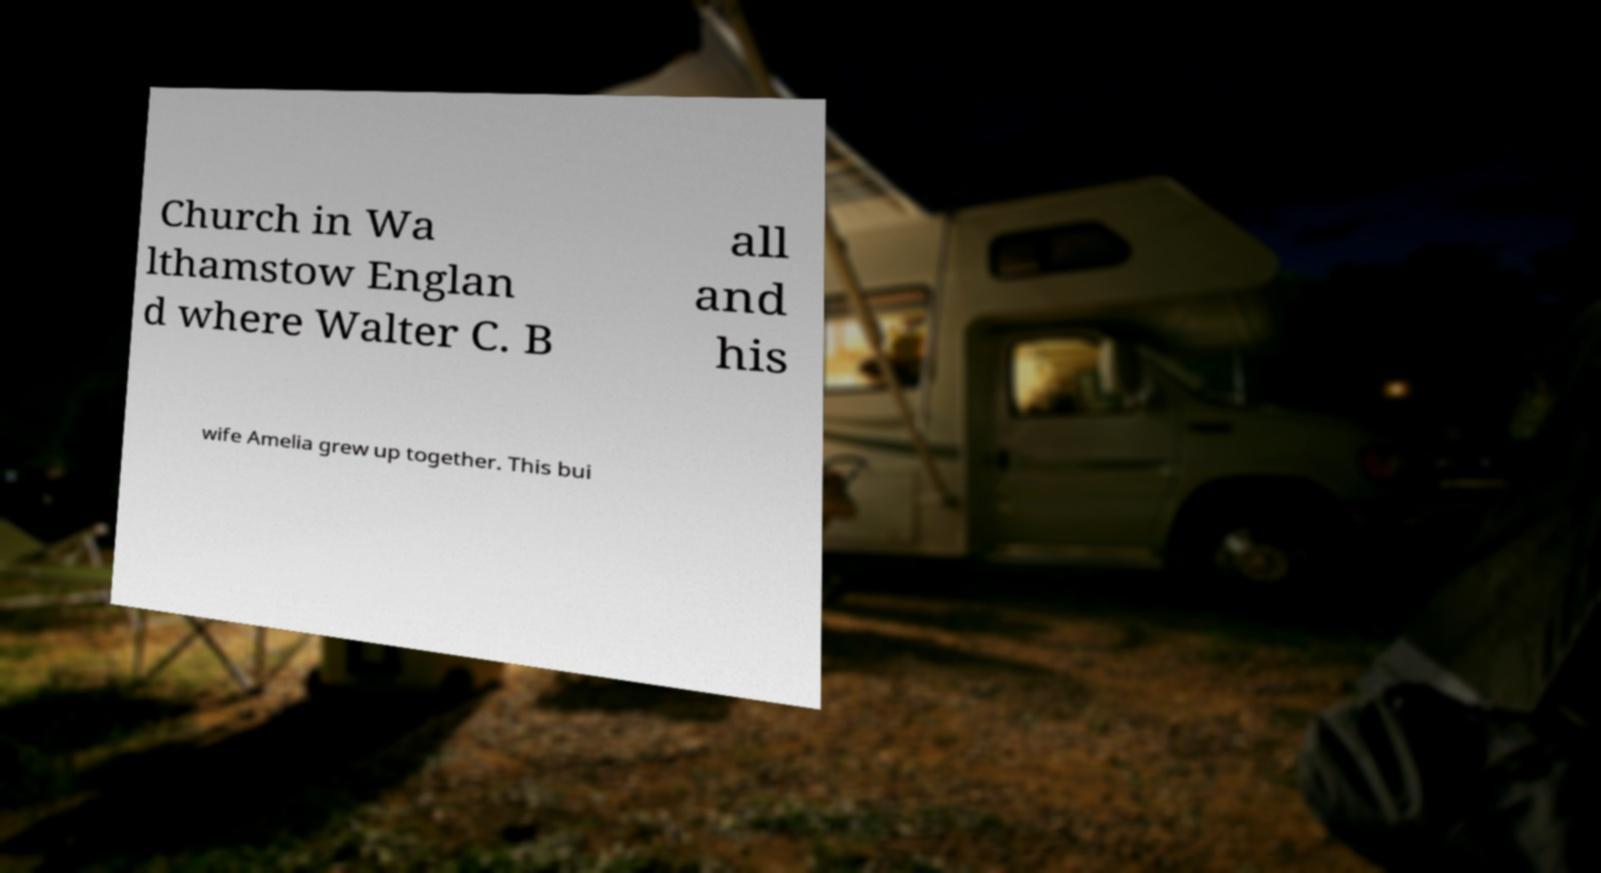Could you extract and type out the text from this image? Church in Wa lthamstow Englan d where Walter C. B all and his wife Amelia grew up together. This bui 